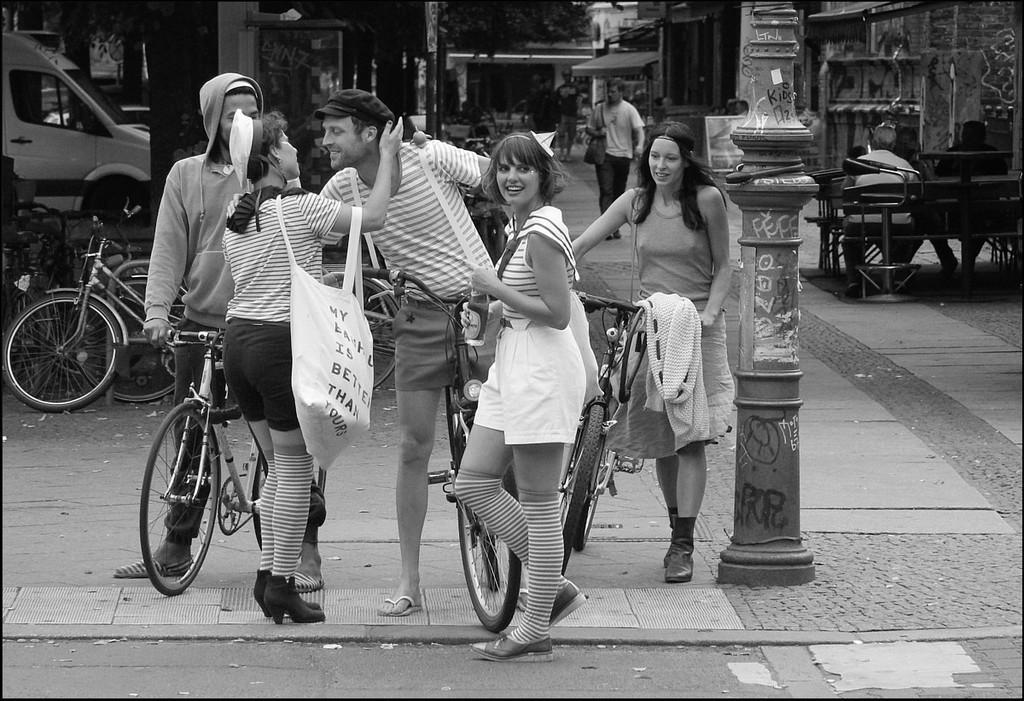Describe this image in one or two sentences. There are five people of which three are woman and five are men , the first woman is holding a bicycle and the second woman is standing and laughing by looking at something the third woman is peeing into another man's face and behind them there are also other people who are walking, to the left side there is a bicycle and a vehicle. In the background there are trees and other buildings. 